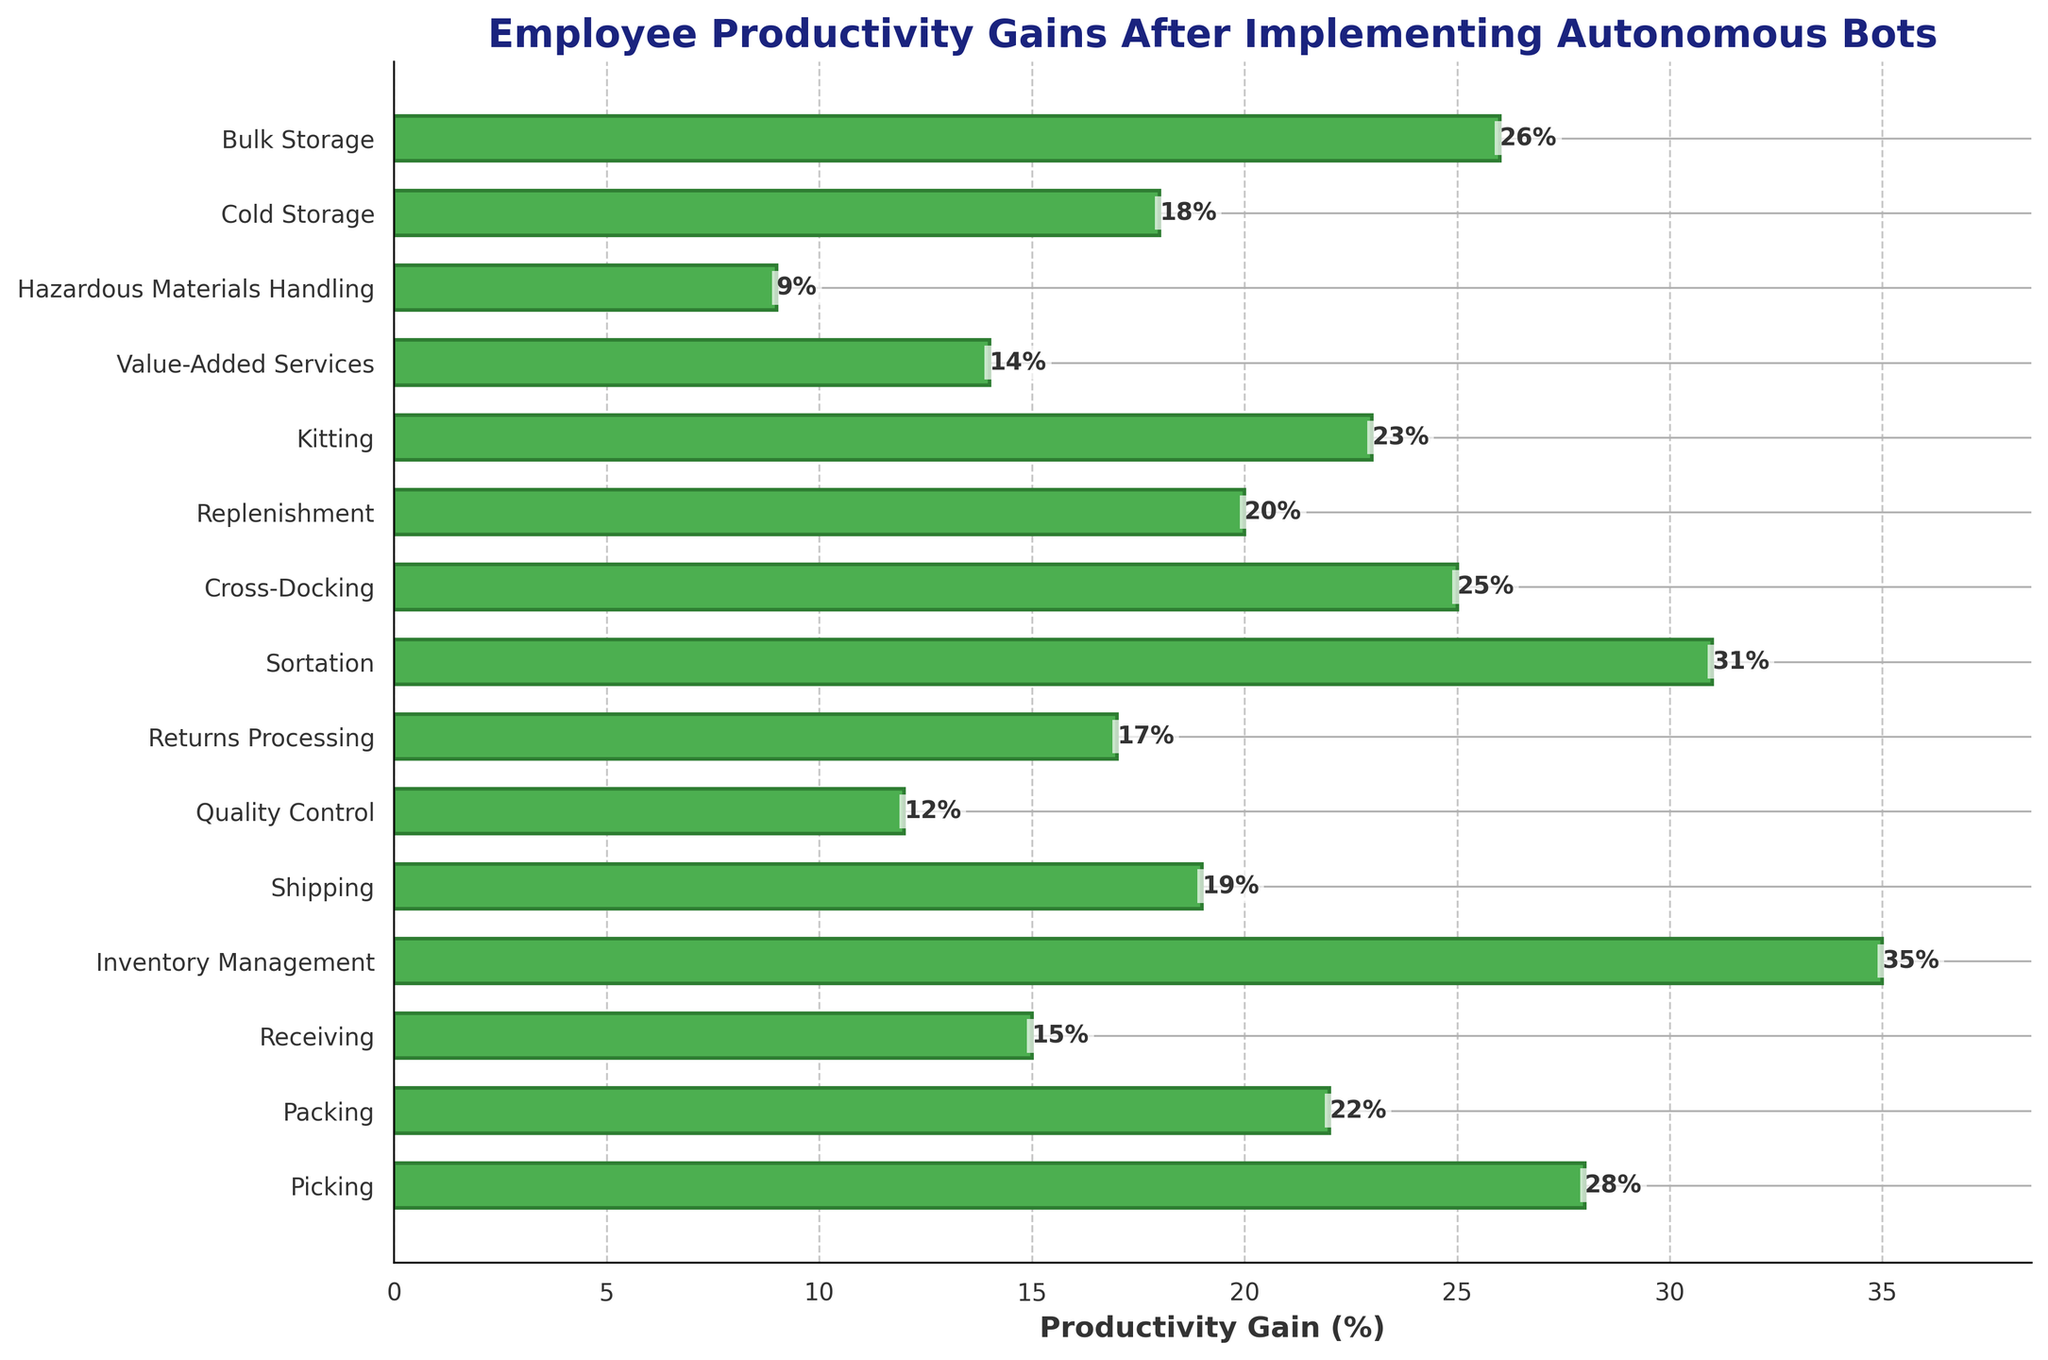What is the range of productivity gains across all departments? The range of a dataset is found by subtracting the smallest value from the largest value. The largest productivity gain is 35% (Inventory Management), and the smallest is 9% (Hazardous Materials Handling). Therefore, the range is calculated as 35 - 9 = 26.
Answer: 26% Which department has the highest productivity gain and what is the value? To find the department with the highest productivity gain, observe the length of the bars in the chart. The bar corresponding to Inventory Management is the longest, indicating the highest gain. The value is labeled next to the bar as 35%.
Answer: Inventory Management, 35% How much higher is the productivity gain in Sortation compared to Shipping? To determine the difference in productivity gains between two departments, subtract the smaller value from the larger. Sortation has a gain of 31%, and Shipping has a gain of 19%. The difference is 31 - 19 = 12.
Answer: 12% What is the average productivity gain across all departments? To calculate the average, sum all productivity gains and then divide by the number of departments. The gains are: 28, 22, 15, 35, 19, 12, 17, 31, 25, 20, 23, 14, 9, 18, 26. Their sum is 314. Dividing by 15 departments gives an average of 314 / 15 ≈ 20.93.
Answer: 20.93% Which departments have a productivity gain greater than 25%? Identify all departments with productivity gains greater than 25% by observing the figure. They are Picking (28%), Inventory Management (35%), Sortation (31%), and Bulk Storage (26%).
Answer: Picking, Inventory Management, Sortation, Bulk Storage How much lower is the productivity gain in Hazardous Materials Handling compared to Picking? To determine the difference in productivity gains, subtract the smaller value from the larger. Hazardous Materials Handling has a gain of 9%, and Picking has a gain of 28%. The difference is 28 - 9 = 19.
Answer: 19% Which department has the lowest productivity gain and what is the value? Observe the shortest bar in the chart, which corresponds to the department with the lowest productivity gain. Hazardous Materials Handling has the shortest bar with a value of 9%.
Answer: Hazardous Materials Handling, 9% What is the total productivity gain of the top three departments? Identify the top three departments by productivity gain: Inventory Management (35%), Sortation (31%), and Picking (28%). Sum these gains: 35 + 31 + 28 = 94.
Answer: 94% What is the productivity gain median value for the departments? Arrange the productivity gains in ascending order and find the median. The sorted gains are: 9, 12, 14, 15, 17, 18, 19, 20, 22, 23, 25, 26, 28, 31, 35. The median is the middle value, which is the 8th value: 20.
Answer: 20% Which department shows the closest productivity gain to the average productivity gain of 20.93%? Identify the department whose productivity gain is closest to 20.93%. The gains of nearby values are: Shipping (19%), Replenishment (20%), and Kitting (23%). Replenishment, with 20%, is the closest.
Answer: Replenishment 